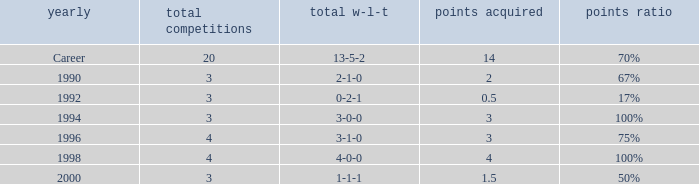Can you tell me the lowest Points won that has the Total matches of 4, and the Total W-L-H of 4-0-0? 4.0. 